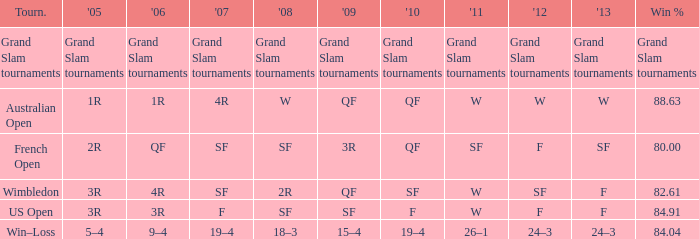WHat in 2005 has a Win % of 82.61? 3R. 